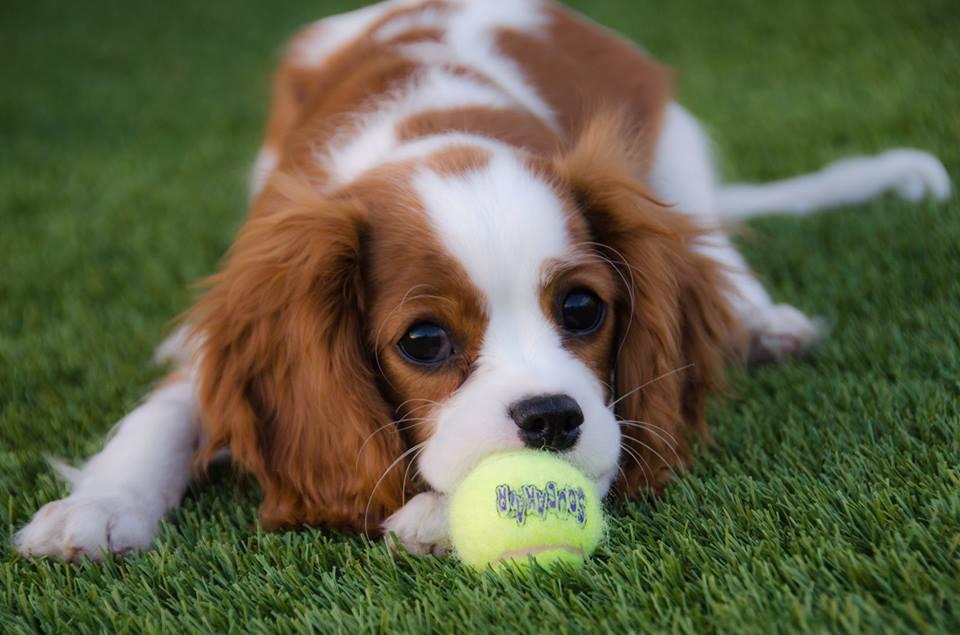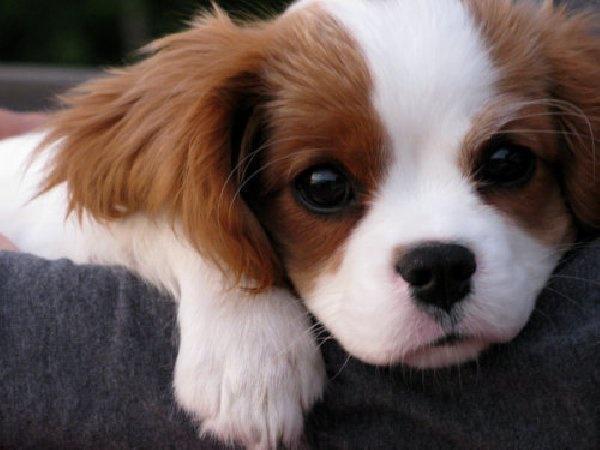The first image is the image on the left, the second image is the image on the right. Examine the images to the left and right. Is the description "An image shows one tan-and-white spaniel reclining directly on green grass." accurate? Answer yes or no. Yes. The first image is the image on the left, the second image is the image on the right. Examine the images to the left and right. Is the description "One of the images contain one dog lying on grass." accurate? Answer yes or no. Yes. 